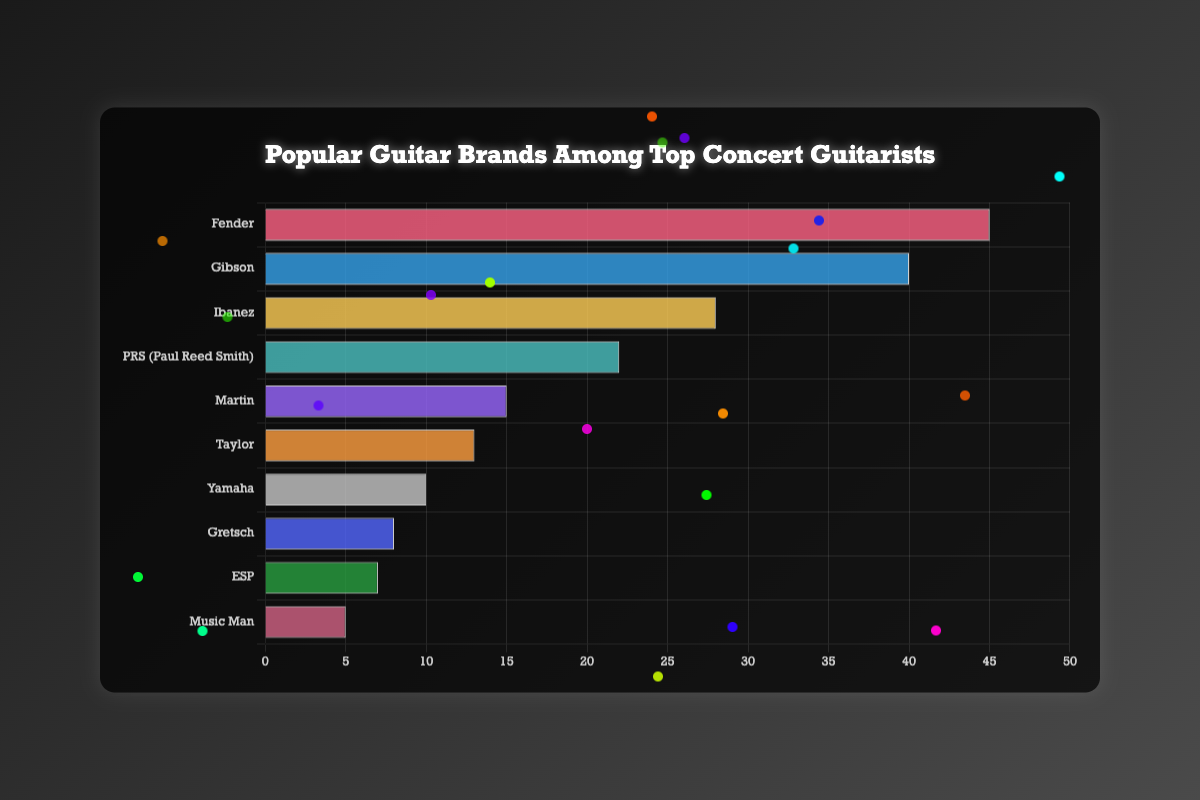Which guitar brand is the most popular among top concert guitarists? By observing the horizontal bars, the longest bar represents the most popular brand. Fender has the longest bar, indicating it is the most popular.
Answer: Fender Which guitar brand is the least popular among top concert guitarists? The shortest bar in the horizontal chart indicates the least popular brand. Music Man has the shortest bar.
Answer: Music Man How many more top concert guitarists use Fender than Gibson? To find the difference, subtract the number of guitarists who prefer Gibson from those who prefer Fender. Fender (45) - Gibson (40) = 5.
Answer: 5 What is the total number of top concert guitarists using PRS and Taylor combined? Sum the number of guitarists who prefer PRS and Taylor. PRS (22) + Taylor (13) = 35.
Answer: 35 Is the number of top concert guitarists using Ibanez greater than those using PRS and Martin combined? First, find the combined number for PRS and Martin, which is 22 (PRS) + 15 (Martin) = 37. Then compare it to Ibanez, which is 28. 28 < 37, so Ibanez is not greater.
Answer: No Which brand has more top concert guitarists: Yamaha or Gretsch? Compare the length of the bars for Yamaha and Gretsch. Yamaha (10) is greater than Gretsch (8).
Answer: Yamaha Which brands have less than 10 top concert guitarists using them? Identify bars with lengths representing numbers less than 10. ESP (7) and Music Man (5) fit this criterion.
Answer: ESP, Music Man What is the average number of top concert guitarists using Taylor, Martin, and Yamaha? Sum the numbers for Taylor, Martin, and Yamaha and then divide by 3. (13 + 15 + 10) / 3 = 38 / 3 ≈ 12.67.
Answer: 12.67 What is the total number of top concert guitarists for all brands combined? Sum the numbers of top concert guitarists for all listed brands. 45 (Fender) + 40 (Gibson) + 28 (Ibanez) + 22 (PRS) + 15 (Martin) + 13 (Taylor) + 10 (Yamaha) + 8 (Gretsch) + 7 (ESP) + 5 (Music Man) = 193.
Answer: 193 